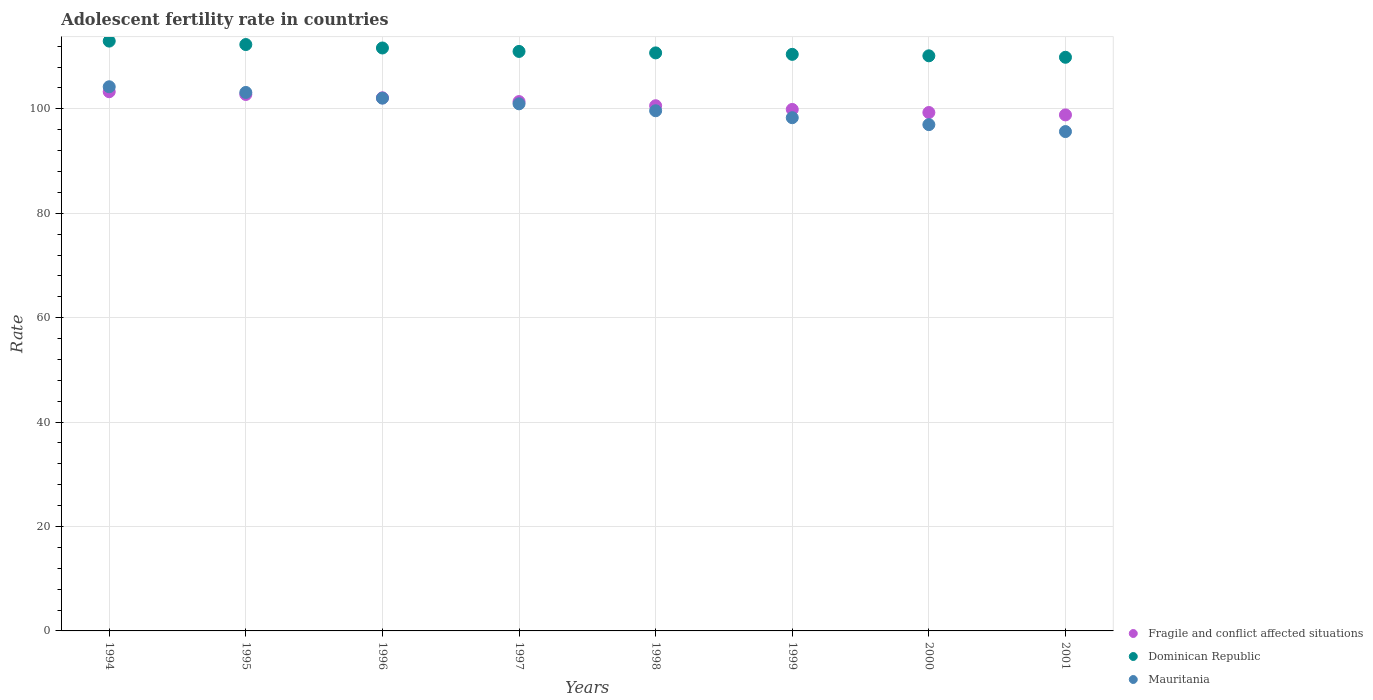How many different coloured dotlines are there?
Your answer should be very brief. 3. What is the adolescent fertility rate in Dominican Republic in 1996?
Offer a very short reply. 111.66. Across all years, what is the maximum adolescent fertility rate in Dominican Republic?
Your response must be concise. 112.98. Across all years, what is the minimum adolescent fertility rate in Mauritania?
Make the answer very short. 95.65. In which year was the adolescent fertility rate in Dominican Republic maximum?
Keep it short and to the point. 1994. What is the total adolescent fertility rate in Mauritania in the graph?
Provide a succinct answer. 800.96. What is the difference between the adolescent fertility rate in Dominican Republic in 1994 and that in 2001?
Your response must be concise. 3.1. What is the difference between the adolescent fertility rate in Mauritania in 1995 and the adolescent fertility rate in Fragile and conflict affected situations in 1996?
Keep it short and to the point. 1.03. What is the average adolescent fertility rate in Dominican Republic per year?
Offer a terse response. 111.14. In the year 1999, what is the difference between the adolescent fertility rate in Dominican Republic and adolescent fertility rate in Fragile and conflict affected situations?
Give a very brief answer. 10.55. What is the ratio of the adolescent fertility rate in Mauritania in 1995 to that in 1998?
Provide a succinct answer. 1.04. Is the difference between the adolescent fertility rate in Dominican Republic in 1994 and 1996 greater than the difference between the adolescent fertility rate in Fragile and conflict affected situations in 1994 and 1996?
Your response must be concise. Yes. What is the difference between the highest and the second highest adolescent fertility rate in Dominican Republic?
Offer a very short reply. 0.66. What is the difference between the highest and the lowest adolescent fertility rate in Fragile and conflict affected situations?
Keep it short and to the point. 4.44. In how many years, is the adolescent fertility rate in Dominican Republic greater than the average adolescent fertility rate in Dominican Republic taken over all years?
Provide a short and direct response. 3. Is the sum of the adolescent fertility rate in Mauritania in 1998 and 1999 greater than the maximum adolescent fertility rate in Dominican Republic across all years?
Provide a short and direct response. Yes. Is it the case that in every year, the sum of the adolescent fertility rate in Dominican Republic and adolescent fertility rate in Fragile and conflict affected situations  is greater than the adolescent fertility rate in Mauritania?
Your response must be concise. Yes. Is the adolescent fertility rate in Dominican Republic strictly greater than the adolescent fertility rate in Fragile and conflict affected situations over the years?
Your response must be concise. Yes. What is the difference between two consecutive major ticks on the Y-axis?
Offer a terse response. 20. Does the graph contain any zero values?
Ensure brevity in your answer.  No. How are the legend labels stacked?
Ensure brevity in your answer.  Vertical. What is the title of the graph?
Your response must be concise. Adolescent fertility rate in countries. Does "European Union" appear as one of the legend labels in the graph?
Give a very brief answer. No. What is the label or title of the X-axis?
Make the answer very short. Years. What is the label or title of the Y-axis?
Ensure brevity in your answer.  Rate. What is the Rate in Fragile and conflict affected situations in 1994?
Make the answer very short. 103.28. What is the Rate of Dominican Republic in 1994?
Your answer should be very brief. 112.98. What is the Rate in Mauritania in 1994?
Provide a short and direct response. 104.23. What is the Rate in Fragile and conflict affected situations in 1995?
Your response must be concise. 102.76. What is the Rate in Dominican Republic in 1995?
Provide a succinct answer. 112.32. What is the Rate of Mauritania in 1995?
Give a very brief answer. 103.14. What is the Rate of Fragile and conflict affected situations in 1996?
Give a very brief answer. 102.11. What is the Rate of Dominican Republic in 1996?
Provide a succinct answer. 111.66. What is the Rate in Mauritania in 1996?
Your answer should be compact. 102.05. What is the Rate of Fragile and conflict affected situations in 1997?
Make the answer very short. 101.39. What is the Rate of Dominican Republic in 1997?
Ensure brevity in your answer.  111. What is the Rate in Mauritania in 1997?
Your answer should be very brief. 100.96. What is the Rate in Fragile and conflict affected situations in 1998?
Ensure brevity in your answer.  100.6. What is the Rate of Dominican Republic in 1998?
Your response must be concise. 110.72. What is the Rate of Mauritania in 1998?
Give a very brief answer. 99.64. What is the Rate of Fragile and conflict affected situations in 1999?
Your answer should be compact. 99.89. What is the Rate of Dominican Republic in 1999?
Provide a succinct answer. 110.44. What is the Rate in Mauritania in 1999?
Your answer should be very brief. 98.31. What is the Rate of Fragile and conflict affected situations in 2000?
Give a very brief answer. 99.3. What is the Rate in Dominican Republic in 2000?
Provide a short and direct response. 110.16. What is the Rate in Mauritania in 2000?
Give a very brief answer. 96.98. What is the Rate of Fragile and conflict affected situations in 2001?
Provide a succinct answer. 98.84. What is the Rate of Dominican Republic in 2001?
Keep it short and to the point. 109.88. What is the Rate of Mauritania in 2001?
Give a very brief answer. 95.65. Across all years, what is the maximum Rate of Fragile and conflict affected situations?
Ensure brevity in your answer.  103.28. Across all years, what is the maximum Rate in Dominican Republic?
Your response must be concise. 112.98. Across all years, what is the maximum Rate of Mauritania?
Offer a terse response. 104.23. Across all years, what is the minimum Rate in Fragile and conflict affected situations?
Offer a very short reply. 98.84. Across all years, what is the minimum Rate in Dominican Republic?
Make the answer very short. 109.88. Across all years, what is the minimum Rate in Mauritania?
Offer a terse response. 95.65. What is the total Rate in Fragile and conflict affected situations in the graph?
Your response must be concise. 808.16. What is the total Rate in Dominican Republic in the graph?
Offer a very short reply. 889.15. What is the total Rate in Mauritania in the graph?
Offer a very short reply. 800.96. What is the difference between the Rate in Fragile and conflict affected situations in 1994 and that in 1995?
Your answer should be very brief. 0.52. What is the difference between the Rate of Dominican Republic in 1994 and that in 1995?
Offer a very short reply. 0.66. What is the difference between the Rate of Mauritania in 1994 and that in 1995?
Ensure brevity in your answer.  1.09. What is the difference between the Rate of Fragile and conflict affected situations in 1994 and that in 1996?
Your answer should be very brief. 1.17. What is the difference between the Rate in Dominican Republic in 1994 and that in 1996?
Provide a succinct answer. 1.32. What is the difference between the Rate in Mauritania in 1994 and that in 1996?
Provide a short and direct response. 2.18. What is the difference between the Rate in Fragile and conflict affected situations in 1994 and that in 1997?
Keep it short and to the point. 1.89. What is the difference between the Rate in Dominican Republic in 1994 and that in 1997?
Ensure brevity in your answer.  1.98. What is the difference between the Rate in Mauritania in 1994 and that in 1997?
Your answer should be compact. 3.27. What is the difference between the Rate in Fragile and conflict affected situations in 1994 and that in 1998?
Provide a short and direct response. 2.68. What is the difference between the Rate in Dominican Republic in 1994 and that in 1998?
Ensure brevity in your answer.  2.26. What is the difference between the Rate of Mauritania in 1994 and that in 1998?
Ensure brevity in your answer.  4.6. What is the difference between the Rate in Fragile and conflict affected situations in 1994 and that in 1999?
Your answer should be compact. 3.39. What is the difference between the Rate of Dominican Republic in 1994 and that in 1999?
Keep it short and to the point. 2.54. What is the difference between the Rate of Mauritania in 1994 and that in 1999?
Keep it short and to the point. 5.92. What is the difference between the Rate of Fragile and conflict affected situations in 1994 and that in 2000?
Offer a very short reply. 3.98. What is the difference between the Rate in Dominican Republic in 1994 and that in 2000?
Give a very brief answer. 2.82. What is the difference between the Rate in Mauritania in 1994 and that in 2000?
Your answer should be very brief. 7.25. What is the difference between the Rate of Fragile and conflict affected situations in 1994 and that in 2001?
Offer a terse response. 4.44. What is the difference between the Rate in Dominican Republic in 1994 and that in 2001?
Ensure brevity in your answer.  3.1. What is the difference between the Rate of Mauritania in 1994 and that in 2001?
Offer a very short reply. 8.58. What is the difference between the Rate of Fragile and conflict affected situations in 1995 and that in 1996?
Provide a short and direct response. 0.64. What is the difference between the Rate of Dominican Republic in 1995 and that in 1996?
Keep it short and to the point. 0.66. What is the difference between the Rate in Mauritania in 1995 and that in 1996?
Provide a short and direct response. 1.09. What is the difference between the Rate of Fragile and conflict affected situations in 1995 and that in 1997?
Your response must be concise. 1.36. What is the difference between the Rate of Dominican Republic in 1995 and that in 1997?
Your response must be concise. 1.32. What is the difference between the Rate in Mauritania in 1995 and that in 1997?
Make the answer very short. 2.18. What is the difference between the Rate of Fragile and conflict affected situations in 1995 and that in 1998?
Provide a short and direct response. 2.16. What is the difference between the Rate in Dominican Republic in 1995 and that in 1998?
Your answer should be very brief. 1.6. What is the difference between the Rate in Mauritania in 1995 and that in 1998?
Offer a very short reply. 3.51. What is the difference between the Rate in Fragile and conflict affected situations in 1995 and that in 1999?
Your response must be concise. 2.87. What is the difference between the Rate in Dominican Republic in 1995 and that in 1999?
Your response must be concise. 1.88. What is the difference between the Rate of Mauritania in 1995 and that in 1999?
Offer a terse response. 4.84. What is the difference between the Rate of Fragile and conflict affected situations in 1995 and that in 2000?
Give a very brief answer. 3.46. What is the difference between the Rate of Dominican Republic in 1995 and that in 2000?
Offer a terse response. 2.16. What is the difference between the Rate of Mauritania in 1995 and that in 2000?
Keep it short and to the point. 6.16. What is the difference between the Rate in Fragile and conflict affected situations in 1995 and that in 2001?
Offer a very short reply. 3.91. What is the difference between the Rate of Dominican Republic in 1995 and that in 2001?
Offer a very short reply. 2.44. What is the difference between the Rate in Mauritania in 1995 and that in 2001?
Your response must be concise. 7.49. What is the difference between the Rate of Fragile and conflict affected situations in 1996 and that in 1997?
Provide a short and direct response. 0.72. What is the difference between the Rate of Dominican Republic in 1996 and that in 1997?
Ensure brevity in your answer.  0.66. What is the difference between the Rate in Mauritania in 1996 and that in 1997?
Your response must be concise. 1.09. What is the difference between the Rate of Fragile and conflict affected situations in 1996 and that in 1998?
Offer a very short reply. 1.51. What is the difference between the Rate of Dominican Republic in 1996 and that in 1998?
Offer a very short reply. 0.94. What is the difference between the Rate in Mauritania in 1996 and that in 1998?
Make the answer very short. 2.42. What is the difference between the Rate of Fragile and conflict affected situations in 1996 and that in 1999?
Keep it short and to the point. 2.22. What is the difference between the Rate in Dominican Republic in 1996 and that in 1999?
Keep it short and to the point. 1.22. What is the difference between the Rate in Mauritania in 1996 and that in 1999?
Your response must be concise. 3.75. What is the difference between the Rate of Fragile and conflict affected situations in 1996 and that in 2000?
Your response must be concise. 2.81. What is the difference between the Rate of Dominican Republic in 1996 and that in 2000?
Give a very brief answer. 1.5. What is the difference between the Rate of Mauritania in 1996 and that in 2000?
Ensure brevity in your answer.  5.08. What is the difference between the Rate of Fragile and conflict affected situations in 1996 and that in 2001?
Provide a short and direct response. 3.27. What is the difference between the Rate in Dominican Republic in 1996 and that in 2001?
Your answer should be compact. 1.78. What is the difference between the Rate of Mauritania in 1996 and that in 2001?
Offer a very short reply. 6.4. What is the difference between the Rate of Fragile and conflict affected situations in 1997 and that in 1998?
Provide a succinct answer. 0.79. What is the difference between the Rate in Dominican Republic in 1997 and that in 1998?
Your answer should be very brief. 0.28. What is the difference between the Rate in Mauritania in 1997 and that in 1998?
Give a very brief answer. 1.33. What is the difference between the Rate of Fragile and conflict affected situations in 1997 and that in 1999?
Your answer should be compact. 1.5. What is the difference between the Rate in Dominican Republic in 1997 and that in 1999?
Ensure brevity in your answer.  0.56. What is the difference between the Rate in Mauritania in 1997 and that in 1999?
Your answer should be compact. 2.66. What is the difference between the Rate in Fragile and conflict affected situations in 1997 and that in 2000?
Offer a very short reply. 2.09. What is the difference between the Rate in Dominican Republic in 1997 and that in 2000?
Your response must be concise. 0.84. What is the difference between the Rate of Mauritania in 1997 and that in 2000?
Make the answer very short. 3.99. What is the difference between the Rate of Fragile and conflict affected situations in 1997 and that in 2001?
Provide a succinct answer. 2.55. What is the difference between the Rate in Dominican Republic in 1997 and that in 2001?
Provide a short and direct response. 1.12. What is the difference between the Rate of Mauritania in 1997 and that in 2001?
Keep it short and to the point. 5.32. What is the difference between the Rate of Fragile and conflict affected situations in 1998 and that in 1999?
Provide a succinct answer. 0.71. What is the difference between the Rate in Dominican Republic in 1998 and that in 1999?
Provide a short and direct response. 0.28. What is the difference between the Rate of Mauritania in 1998 and that in 1999?
Your answer should be very brief. 1.33. What is the difference between the Rate in Fragile and conflict affected situations in 1998 and that in 2000?
Keep it short and to the point. 1.3. What is the difference between the Rate in Dominican Republic in 1998 and that in 2000?
Give a very brief answer. 0.56. What is the difference between the Rate of Mauritania in 1998 and that in 2000?
Ensure brevity in your answer.  2.66. What is the difference between the Rate of Fragile and conflict affected situations in 1998 and that in 2001?
Make the answer very short. 1.76. What is the difference between the Rate in Dominican Republic in 1998 and that in 2001?
Keep it short and to the point. 0.84. What is the difference between the Rate in Mauritania in 1998 and that in 2001?
Ensure brevity in your answer.  3.99. What is the difference between the Rate of Fragile and conflict affected situations in 1999 and that in 2000?
Ensure brevity in your answer.  0.59. What is the difference between the Rate in Dominican Republic in 1999 and that in 2000?
Make the answer very short. 0.28. What is the difference between the Rate in Mauritania in 1999 and that in 2000?
Your response must be concise. 1.33. What is the difference between the Rate of Fragile and conflict affected situations in 1999 and that in 2001?
Ensure brevity in your answer.  1.05. What is the difference between the Rate of Dominican Republic in 1999 and that in 2001?
Provide a succinct answer. 0.56. What is the difference between the Rate in Mauritania in 1999 and that in 2001?
Ensure brevity in your answer.  2.66. What is the difference between the Rate of Fragile and conflict affected situations in 2000 and that in 2001?
Make the answer very short. 0.46. What is the difference between the Rate of Dominican Republic in 2000 and that in 2001?
Provide a succinct answer. 0.28. What is the difference between the Rate in Mauritania in 2000 and that in 2001?
Your answer should be compact. 1.33. What is the difference between the Rate in Fragile and conflict affected situations in 1994 and the Rate in Dominican Republic in 1995?
Make the answer very short. -9.04. What is the difference between the Rate in Fragile and conflict affected situations in 1994 and the Rate in Mauritania in 1995?
Ensure brevity in your answer.  0.14. What is the difference between the Rate in Dominican Republic in 1994 and the Rate in Mauritania in 1995?
Give a very brief answer. 9.84. What is the difference between the Rate of Fragile and conflict affected situations in 1994 and the Rate of Dominican Republic in 1996?
Make the answer very short. -8.38. What is the difference between the Rate in Fragile and conflict affected situations in 1994 and the Rate in Mauritania in 1996?
Provide a succinct answer. 1.23. What is the difference between the Rate of Dominican Republic in 1994 and the Rate of Mauritania in 1996?
Offer a very short reply. 10.93. What is the difference between the Rate in Fragile and conflict affected situations in 1994 and the Rate in Dominican Republic in 1997?
Keep it short and to the point. -7.72. What is the difference between the Rate of Fragile and conflict affected situations in 1994 and the Rate of Mauritania in 1997?
Ensure brevity in your answer.  2.32. What is the difference between the Rate of Dominican Republic in 1994 and the Rate of Mauritania in 1997?
Your response must be concise. 12.01. What is the difference between the Rate of Fragile and conflict affected situations in 1994 and the Rate of Dominican Republic in 1998?
Your response must be concise. -7.44. What is the difference between the Rate in Fragile and conflict affected situations in 1994 and the Rate in Mauritania in 1998?
Offer a terse response. 3.64. What is the difference between the Rate of Dominican Republic in 1994 and the Rate of Mauritania in 1998?
Your answer should be very brief. 13.34. What is the difference between the Rate in Fragile and conflict affected situations in 1994 and the Rate in Dominican Republic in 1999?
Your answer should be compact. -7.16. What is the difference between the Rate in Fragile and conflict affected situations in 1994 and the Rate in Mauritania in 1999?
Your response must be concise. 4.97. What is the difference between the Rate of Dominican Republic in 1994 and the Rate of Mauritania in 1999?
Provide a short and direct response. 14.67. What is the difference between the Rate of Fragile and conflict affected situations in 1994 and the Rate of Dominican Republic in 2000?
Keep it short and to the point. -6.88. What is the difference between the Rate of Fragile and conflict affected situations in 1994 and the Rate of Mauritania in 2000?
Keep it short and to the point. 6.3. What is the difference between the Rate of Dominican Republic in 1994 and the Rate of Mauritania in 2000?
Provide a succinct answer. 16. What is the difference between the Rate in Fragile and conflict affected situations in 1994 and the Rate in Dominican Republic in 2001?
Your answer should be very brief. -6.6. What is the difference between the Rate of Fragile and conflict affected situations in 1994 and the Rate of Mauritania in 2001?
Your answer should be very brief. 7.63. What is the difference between the Rate in Dominican Republic in 1994 and the Rate in Mauritania in 2001?
Offer a terse response. 17.33. What is the difference between the Rate of Fragile and conflict affected situations in 1995 and the Rate of Dominican Republic in 1996?
Provide a succinct answer. -8.9. What is the difference between the Rate of Fragile and conflict affected situations in 1995 and the Rate of Mauritania in 1996?
Provide a succinct answer. 0.7. What is the difference between the Rate of Dominican Republic in 1995 and the Rate of Mauritania in 1996?
Provide a succinct answer. 10.27. What is the difference between the Rate in Fragile and conflict affected situations in 1995 and the Rate in Dominican Republic in 1997?
Make the answer very short. -8.24. What is the difference between the Rate of Fragile and conflict affected situations in 1995 and the Rate of Mauritania in 1997?
Give a very brief answer. 1.79. What is the difference between the Rate of Dominican Republic in 1995 and the Rate of Mauritania in 1997?
Make the answer very short. 11.35. What is the difference between the Rate in Fragile and conflict affected situations in 1995 and the Rate in Dominican Republic in 1998?
Give a very brief answer. -7.96. What is the difference between the Rate in Fragile and conflict affected situations in 1995 and the Rate in Mauritania in 1998?
Make the answer very short. 3.12. What is the difference between the Rate in Dominican Republic in 1995 and the Rate in Mauritania in 1998?
Make the answer very short. 12.68. What is the difference between the Rate of Fragile and conflict affected situations in 1995 and the Rate of Dominican Republic in 1999?
Keep it short and to the point. -7.68. What is the difference between the Rate in Fragile and conflict affected situations in 1995 and the Rate in Mauritania in 1999?
Keep it short and to the point. 4.45. What is the difference between the Rate of Dominican Republic in 1995 and the Rate of Mauritania in 1999?
Your answer should be compact. 14.01. What is the difference between the Rate in Fragile and conflict affected situations in 1995 and the Rate in Dominican Republic in 2000?
Your response must be concise. -7.4. What is the difference between the Rate of Fragile and conflict affected situations in 1995 and the Rate of Mauritania in 2000?
Ensure brevity in your answer.  5.78. What is the difference between the Rate of Dominican Republic in 1995 and the Rate of Mauritania in 2000?
Ensure brevity in your answer.  15.34. What is the difference between the Rate of Fragile and conflict affected situations in 1995 and the Rate of Dominican Republic in 2001?
Offer a very short reply. -7.12. What is the difference between the Rate in Fragile and conflict affected situations in 1995 and the Rate in Mauritania in 2001?
Ensure brevity in your answer.  7.11. What is the difference between the Rate of Dominican Republic in 1995 and the Rate of Mauritania in 2001?
Your response must be concise. 16.67. What is the difference between the Rate in Fragile and conflict affected situations in 1996 and the Rate in Dominican Republic in 1997?
Keep it short and to the point. -8.89. What is the difference between the Rate of Fragile and conflict affected situations in 1996 and the Rate of Mauritania in 1997?
Your response must be concise. 1.15. What is the difference between the Rate of Dominican Republic in 1996 and the Rate of Mauritania in 1997?
Your answer should be very brief. 10.69. What is the difference between the Rate of Fragile and conflict affected situations in 1996 and the Rate of Dominican Republic in 1998?
Provide a short and direct response. -8.61. What is the difference between the Rate in Fragile and conflict affected situations in 1996 and the Rate in Mauritania in 1998?
Offer a very short reply. 2.48. What is the difference between the Rate of Dominican Republic in 1996 and the Rate of Mauritania in 1998?
Your answer should be very brief. 12.02. What is the difference between the Rate in Fragile and conflict affected situations in 1996 and the Rate in Dominican Republic in 1999?
Provide a short and direct response. -8.33. What is the difference between the Rate in Fragile and conflict affected situations in 1996 and the Rate in Mauritania in 1999?
Give a very brief answer. 3.8. What is the difference between the Rate of Dominican Republic in 1996 and the Rate of Mauritania in 1999?
Provide a short and direct response. 13.35. What is the difference between the Rate of Fragile and conflict affected situations in 1996 and the Rate of Dominican Republic in 2000?
Give a very brief answer. -8.05. What is the difference between the Rate in Fragile and conflict affected situations in 1996 and the Rate in Mauritania in 2000?
Make the answer very short. 5.13. What is the difference between the Rate in Dominican Republic in 1996 and the Rate in Mauritania in 2000?
Your answer should be compact. 14.68. What is the difference between the Rate of Fragile and conflict affected situations in 1996 and the Rate of Dominican Republic in 2001?
Provide a short and direct response. -7.77. What is the difference between the Rate in Fragile and conflict affected situations in 1996 and the Rate in Mauritania in 2001?
Your response must be concise. 6.46. What is the difference between the Rate of Dominican Republic in 1996 and the Rate of Mauritania in 2001?
Offer a terse response. 16.01. What is the difference between the Rate in Fragile and conflict affected situations in 1997 and the Rate in Dominican Republic in 1998?
Provide a succinct answer. -9.33. What is the difference between the Rate in Fragile and conflict affected situations in 1997 and the Rate in Mauritania in 1998?
Offer a terse response. 1.76. What is the difference between the Rate in Dominican Republic in 1997 and the Rate in Mauritania in 1998?
Offer a terse response. 11.36. What is the difference between the Rate in Fragile and conflict affected situations in 1997 and the Rate in Dominican Republic in 1999?
Make the answer very short. -9.05. What is the difference between the Rate of Fragile and conflict affected situations in 1997 and the Rate of Mauritania in 1999?
Your answer should be very brief. 3.08. What is the difference between the Rate in Dominican Republic in 1997 and the Rate in Mauritania in 1999?
Give a very brief answer. 12.69. What is the difference between the Rate in Fragile and conflict affected situations in 1997 and the Rate in Dominican Republic in 2000?
Offer a terse response. -8.77. What is the difference between the Rate of Fragile and conflict affected situations in 1997 and the Rate of Mauritania in 2000?
Your response must be concise. 4.41. What is the difference between the Rate of Dominican Republic in 1997 and the Rate of Mauritania in 2000?
Your answer should be very brief. 14.02. What is the difference between the Rate in Fragile and conflict affected situations in 1997 and the Rate in Dominican Republic in 2001?
Offer a very short reply. -8.49. What is the difference between the Rate of Fragile and conflict affected situations in 1997 and the Rate of Mauritania in 2001?
Offer a terse response. 5.74. What is the difference between the Rate of Dominican Republic in 1997 and the Rate of Mauritania in 2001?
Make the answer very short. 15.35. What is the difference between the Rate of Fragile and conflict affected situations in 1998 and the Rate of Dominican Republic in 1999?
Provide a succinct answer. -9.84. What is the difference between the Rate in Fragile and conflict affected situations in 1998 and the Rate in Mauritania in 1999?
Provide a succinct answer. 2.29. What is the difference between the Rate of Dominican Republic in 1998 and the Rate of Mauritania in 1999?
Keep it short and to the point. 12.41. What is the difference between the Rate of Fragile and conflict affected situations in 1998 and the Rate of Dominican Republic in 2000?
Provide a short and direct response. -9.56. What is the difference between the Rate in Fragile and conflict affected situations in 1998 and the Rate in Mauritania in 2000?
Provide a succinct answer. 3.62. What is the difference between the Rate of Dominican Republic in 1998 and the Rate of Mauritania in 2000?
Offer a terse response. 13.74. What is the difference between the Rate of Fragile and conflict affected situations in 1998 and the Rate of Dominican Republic in 2001?
Your answer should be very brief. -9.28. What is the difference between the Rate in Fragile and conflict affected situations in 1998 and the Rate in Mauritania in 2001?
Ensure brevity in your answer.  4.95. What is the difference between the Rate of Dominican Republic in 1998 and the Rate of Mauritania in 2001?
Provide a short and direct response. 15.07. What is the difference between the Rate in Fragile and conflict affected situations in 1999 and the Rate in Dominican Republic in 2000?
Provide a short and direct response. -10.27. What is the difference between the Rate of Fragile and conflict affected situations in 1999 and the Rate of Mauritania in 2000?
Give a very brief answer. 2.91. What is the difference between the Rate in Dominican Republic in 1999 and the Rate in Mauritania in 2000?
Keep it short and to the point. 13.46. What is the difference between the Rate in Fragile and conflict affected situations in 1999 and the Rate in Dominican Republic in 2001?
Your answer should be compact. -9.99. What is the difference between the Rate in Fragile and conflict affected situations in 1999 and the Rate in Mauritania in 2001?
Provide a short and direct response. 4.24. What is the difference between the Rate in Dominican Republic in 1999 and the Rate in Mauritania in 2001?
Give a very brief answer. 14.79. What is the difference between the Rate of Fragile and conflict affected situations in 2000 and the Rate of Dominican Republic in 2001?
Make the answer very short. -10.58. What is the difference between the Rate in Fragile and conflict affected situations in 2000 and the Rate in Mauritania in 2001?
Keep it short and to the point. 3.65. What is the difference between the Rate in Dominican Republic in 2000 and the Rate in Mauritania in 2001?
Give a very brief answer. 14.51. What is the average Rate in Fragile and conflict affected situations per year?
Provide a short and direct response. 101.02. What is the average Rate of Dominican Republic per year?
Provide a short and direct response. 111.14. What is the average Rate in Mauritania per year?
Offer a very short reply. 100.12. In the year 1994, what is the difference between the Rate in Fragile and conflict affected situations and Rate in Dominican Republic?
Make the answer very short. -9.7. In the year 1994, what is the difference between the Rate of Fragile and conflict affected situations and Rate of Mauritania?
Make the answer very short. -0.95. In the year 1994, what is the difference between the Rate in Dominican Republic and Rate in Mauritania?
Provide a short and direct response. 8.75. In the year 1995, what is the difference between the Rate of Fragile and conflict affected situations and Rate of Dominican Republic?
Provide a succinct answer. -9.56. In the year 1995, what is the difference between the Rate in Fragile and conflict affected situations and Rate in Mauritania?
Your response must be concise. -0.39. In the year 1995, what is the difference between the Rate in Dominican Republic and Rate in Mauritania?
Your answer should be very brief. 9.18. In the year 1996, what is the difference between the Rate in Fragile and conflict affected situations and Rate in Dominican Republic?
Your answer should be compact. -9.55. In the year 1996, what is the difference between the Rate of Fragile and conflict affected situations and Rate of Mauritania?
Offer a very short reply. 0.06. In the year 1996, what is the difference between the Rate of Dominican Republic and Rate of Mauritania?
Your answer should be very brief. 9.61. In the year 1997, what is the difference between the Rate of Fragile and conflict affected situations and Rate of Dominican Republic?
Give a very brief answer. -9.61. In the year 1997, what is the difference between the Rate of Fragile and conflict affected situations and Rate of Mauritania?
Your response must be concise. 0.43. In the year 1997, what is the difference between the Rate in Dominican Republic and Rate in Mauritania?
Offer a terse response. 10.04. In the year 1998, what is the difference between the Rate in Fragile and conflict affected situations and Rate in Dominican Republic?
Provide a succinct answer. -10.12. In the year 1998, what is the difference between the Rate in Fragile and conflict affected situations and Rate in Mauritania?
Provide a succinct answer. 0.96. In the year 1998, what is the difference between the Rate of Dominican Republic and Rate of Mauritania?
Offer a very short reply. 11.08. In the year 1999, what is the difference between the Rate in Fragile and conflict affected situations and Rate in Dominican Republic?
Provide a short and direct response. -10.55. In the year 1999, what is the difference between the Rate of Fragile and conflict affected situations and Rate of Mauritania?
Make the answer very short. 1.58. In the year 1999, what is the difference between the Rate in Dominican Republic and Rate in Mauritania?
Your answer should be very brief. 12.13. In the year 2000, what is the difference between the Rate in Fragile and conflict affected situations and Rate in Dominican Republic?
Offer a terse response. -10.86. In the year 2000, what is the difference between the Rate in Fragile and conflict affected situations and Rate in Mauritania?
Make the answer very short. 2.32. In the year 2000, what is the difference between the Rate of Dominican Republic and Rate of Mauritania?
Give a very brief answer. 13.18. In the year 2001, what is the difference between the Rate in Fragile and conflict affected situations and Rate in Dominican Republic?
Your response must be concise. -11.04. In the year 2001, what is the difference between the Rate in Fragile and conflict affected situations and Rate in Mauritania?
Provide a short and direct response. 3.19. In the year 2001, what is the difference between the Rate of Dominican Republic and Rate of Mauritania?
Your response must be concise. 14.23. What is the ratio of the Rate of Dominican Republic in 1994 to that in 1995?
Your response must be concise. 1.01. What is the ratio of the Rate of Mauritania in 1994 to that in 1995?
Ensure brevity in your answer.  1.01. What is the ratio of the Rate of Fragile and conflict affected situations in 1994 to that in 1996?
Offer a terse response. 1.01. What is the ratio of the Rate in Dominican Republic in 1994 to that in 1996?
Ensure brevity in your answer.  1.01. What is the ratio of the Rate in Mauritania in 1994 to that in 1996?
Offer a terse response. 1.02. What is the ratio of the Rate in Fragile and conflict affected situations in 1994 to that in 1997?
Your response must be concise. 1.02. What is the ratio of the Rate of Dominican Republic in 1994 to that in 1997?
Offer a very short reply. 1.02. What is the ratio of the Rate of Mauritania in 1994 to that in 1997?
Give a very brief answer. 1.03. What is the ratio of the Rate in Fragile and conflict affected situations in 1994 to that in 1998?
Make the answer very short. 1.03. What is the ratio of the Rate of Dominican Republic in 1994 to that in 1998?
Offer a terse response. 1.02. What is the ratio of the Rate of Mauritania in 1994 to that in 1998?
Provide a succinct answer. 1.05. What is the ratio of the Rate in Fragile and conflict affected situations in 1994 to that in 1999?
Your answer should be very brief. 1.03. What is the ratio of the Rate of Dominican Republic in 1994 to that in 1999?
Offer a very short reply. 1.02. What is the ratio of the Rate of Mauritania in 1994 to that in 1999?
Provide a short and direct response. 1.06. What is the ratio of the Rate of Fragile and conflict affected situations in 1994 to that in 2000?
Provide a short and direct response. 1.04. What is the ratio of the Rate in Dominican Republic in 1994 to that in 2000?
Keep it short and to the point. 1.03. What is the ratio of the Rate of Mauritania in 1994 to that in 2000?
Give a very brief answer. 1.07. What is the ratio of the Rate in Fragile and conflict affected situations in 1994 to that in 2001?
Your answer should be very brief. 1.04. What is the ratio of the Rate in Dominican Republic in 1994 to that in 2001?
Give a very brief answer. 1.03. What is the ratio of the Rate of Mauritania in 1994 to that in 2001?
Ensure brevity in your answer.  1.09. What is the ratio of the Rate in Dominican Republic in 1995 to that in 1996?
Give a very brief answer. 1.01. What is the ratio of the Rate of Mauritania in 1995 to that in 1996?
Give a very brief answer. 1.01. What is the ratio of the Rate of Fragile and conflict affected situations in 1995 to that in 1997?
Ensure brevity in your answer.  1.01. What is the ratio of the Rate of Dominican Republic in 1995 to that in 1997?
Your response must be concise. 1.01. What is the ratio of the Rate of Mauritania in 1995 to that in 1997?
Ensure brevity in your answer.  1.02. What is the ratio of the Rate in Fragile and conflict affected situations in 1995 to that in 1998?
Make the answer very short. 1.02. What is the ratio of the Rate in Dominican Republic in 1995 to that in 1998?
Provide a succinct answer. 1.01. What is the ratio of the Rate in Mauritania in 1995 to that in 1998?
Make the answer very short. 1.04. What is the ratio of the Rate in Fragile and conflict affected situations in 1995 to that in 1999?
Keep it short and to the point. 1.03. What is the ratio of the Rate in Mauritania in 1995 to that in 1999?
Keep it short and to the point. 1.05. What is the ratio of the Rate of Fragile and conflict affected situations in 1995 to that in 2000?
Make the answer very short. 1.03. What is the ratio of the Rate in Dominican Republic in 1995 to that in 2000?
Provide a short and direct response. 1.02. What is the ratio of the Rate of Mauritania in 1995 to that in 2000?
Keep it short and to the point. 1.06. What is the ratio of the Rate of Fragile and conflict affected situations in 1995 to that in 2001?
Provide a succinct answer. 1.04. What is the ratio of the Rate of Dominican Republic in 1995 to that in 2001?
Offer a terse response. 1.02. What is the ratio of the Rate of Mauritania in 1995 to that in 2001?
Ensure brevity in your answer.  1.08. What is the ratio of the Rate in Fragile and conflict affected situations in 1996 to that in 1997?
Offer a terse response. 1.01. What is the ratio of the Rate in Dominican Republic in 1996 to that in 1997?
Offer a very short reply. 1.01. What is the ratio of the Rate of Mauritania in 1996 to that in 1997?
Make the answer very short. 1.01. What is the ratio of the Rate of Dominican Republic in 1996 to that in 1998?
Ensure brevity in your answer.  1.01. What is the ratio of the Rate in Mauritania in 1996 to that in 1998?
Your response must be concise. 1.02. What is the ratio of the Rate of Fragile and conflict affected situations in 1996 to that in 1999?
Provide a succinct answer. 1.02. What is the ratio of the Rate in Dominican Republic in 1996 to that in 1999?
Provide a short and direct response. 1.01. What is the ratio of the Rate of Mauritania in 1996 to that in 1999?
Your answer should be compact. 1.04. What is the ratio of the Rate in Fragile and conflict affected situations in 1996 to that in 2000?
Your answer should be very brief. 1.03. What is the ratio of the Rate in Dominican Republic in 1996 to that in 2000?
Make the answer very short. 1.01. What is the ratio of the Rate of Mauritania in 1996 to that in 2000?
Provide a succinct answer. 1.05. What is the ratio of the Rate of Fragile and conflict affected situations in 1996 to that in 2001?
Provide a short and direct response. 1.03. What is the ratio of the Rate of Dominican Republic in 1996 to that in 2001?
Give a very brief answer. 1.02. What is the ratio of the Rate in Mauritania in 1996 to that in 2001?
Provide a succinct answer. 1.07. What is the ratio of the Rate in Fragile and conflict affected situations in 1997 to that in 1998?
Your answer should be very brief. 1.01. What is the ratio of the Rate of Dominican Republic in 1997 to that in 1998?
Your answer should be very brief. 1. What is the ratio of the Rate of Mauritania in 1997 to that in 1998?
Provide a short and direct response. 1.01. What is the ratio of the Rate in Fragile and conflict affected situations in 1997 to that in 1999?
Your response must be concise. 1.02. What is the ratio of the Rate in Fragile and conflict affected situations in 1997 to that in 2000?
Your answer should be very brief. 1.02. What is the ratio of the Rate of Dominican Republic in 1997 to that in 2000?
Ensure brevity in your answer.  1.01. What is the ratio of the Rate in Mauritania in 1997 to that in 2000?
Ensure brevity in your answer.  1.04. What is the ratio of the Rate of Fragile and conflict affected situations in 1997 to that in 2001?
Your response must be concise. 1.03. What is the ratio of the Rate in Dominican Republic in 1997 to that in 2001?
Your response must be concise. 1.01. What is the ratio of the Rate in Mauritania in 1997 to that in 2001?
Keep it short and to the point. 1.06. What is the ratio of the Rate of Fragile and conflict affected situations in 1998 to that in 1999?
Your response must be concise. 1.01. What is the ratio of the Rate of Mauritania in 1998 to that in 1999?
Give a very brief answer. 1.01. What is the ratio of the Rate of Fragile and conflict affected situations in 1998 to that in 2000?
Give a very brief answer. 1.01. What is the ratio of the Rate of Mauritania in 1998 to that in 2000?
Make the answer very short. 1.03. What is the ratio of the Rate of Fragile and conflict affected situations in 1998 to that in 2001?
Give a very brief answer. 1.02. What is the ratio of the Rate in Dominican Republic in 1998 to that in 2001?
Your answer should be compact. 1.01. What is the ratio of the Rate of Mauritania in 1998 to that in 2001?
Your response must be concise. 1.04. What is the ratio of the Rate of Fragile and conflict affected situations in 1999 to that in 2000?
Provide a succinct answer. 1.01. What is the ratio of the Rate in Mauritania in 1999 to that in 2000?
Keep it short and to the point. 1.01. What is the ratio of the Rate in Fragile and conflict affected situations in 1999 to that in 2001?
Your answer should be compact. 1.01. What is the ratio of the Rate of Mauritania in 1999 to that in 2001?
Offer a very short reply. 1.03. What is the ratio of the Rate of Dominican Republic in 2000 to that in 2001?
Your response must be concise. 1. What is the ratio of the Rate of Mauritania in 2000 to that in 2001?
Provide a short and direct response. 1.01. What is the difference between the highest and the second highest Rate of Fragile and conflict affected situations?
Ensure brevity in your answer.  0.52. What is the difference between the highest and the second highest Rate of Dominican Republic?
Your answer should be very brief. 0.66. What is the difference between the highest and the second highest Rate in Mauritania?
Offer a terse response. 1.09. What is the difference between the highest and the lowest Rate in Fragile and conflict affected situations?
Keep it short and to the point. 4.44. What is the difference between the highest and the lowest Rate of Dominican Republic?
Offer a terse response. 3.1. What is the difference between the highest and the lowest Rate of Mauritania?
Provide a short and direct response. 8.58. 